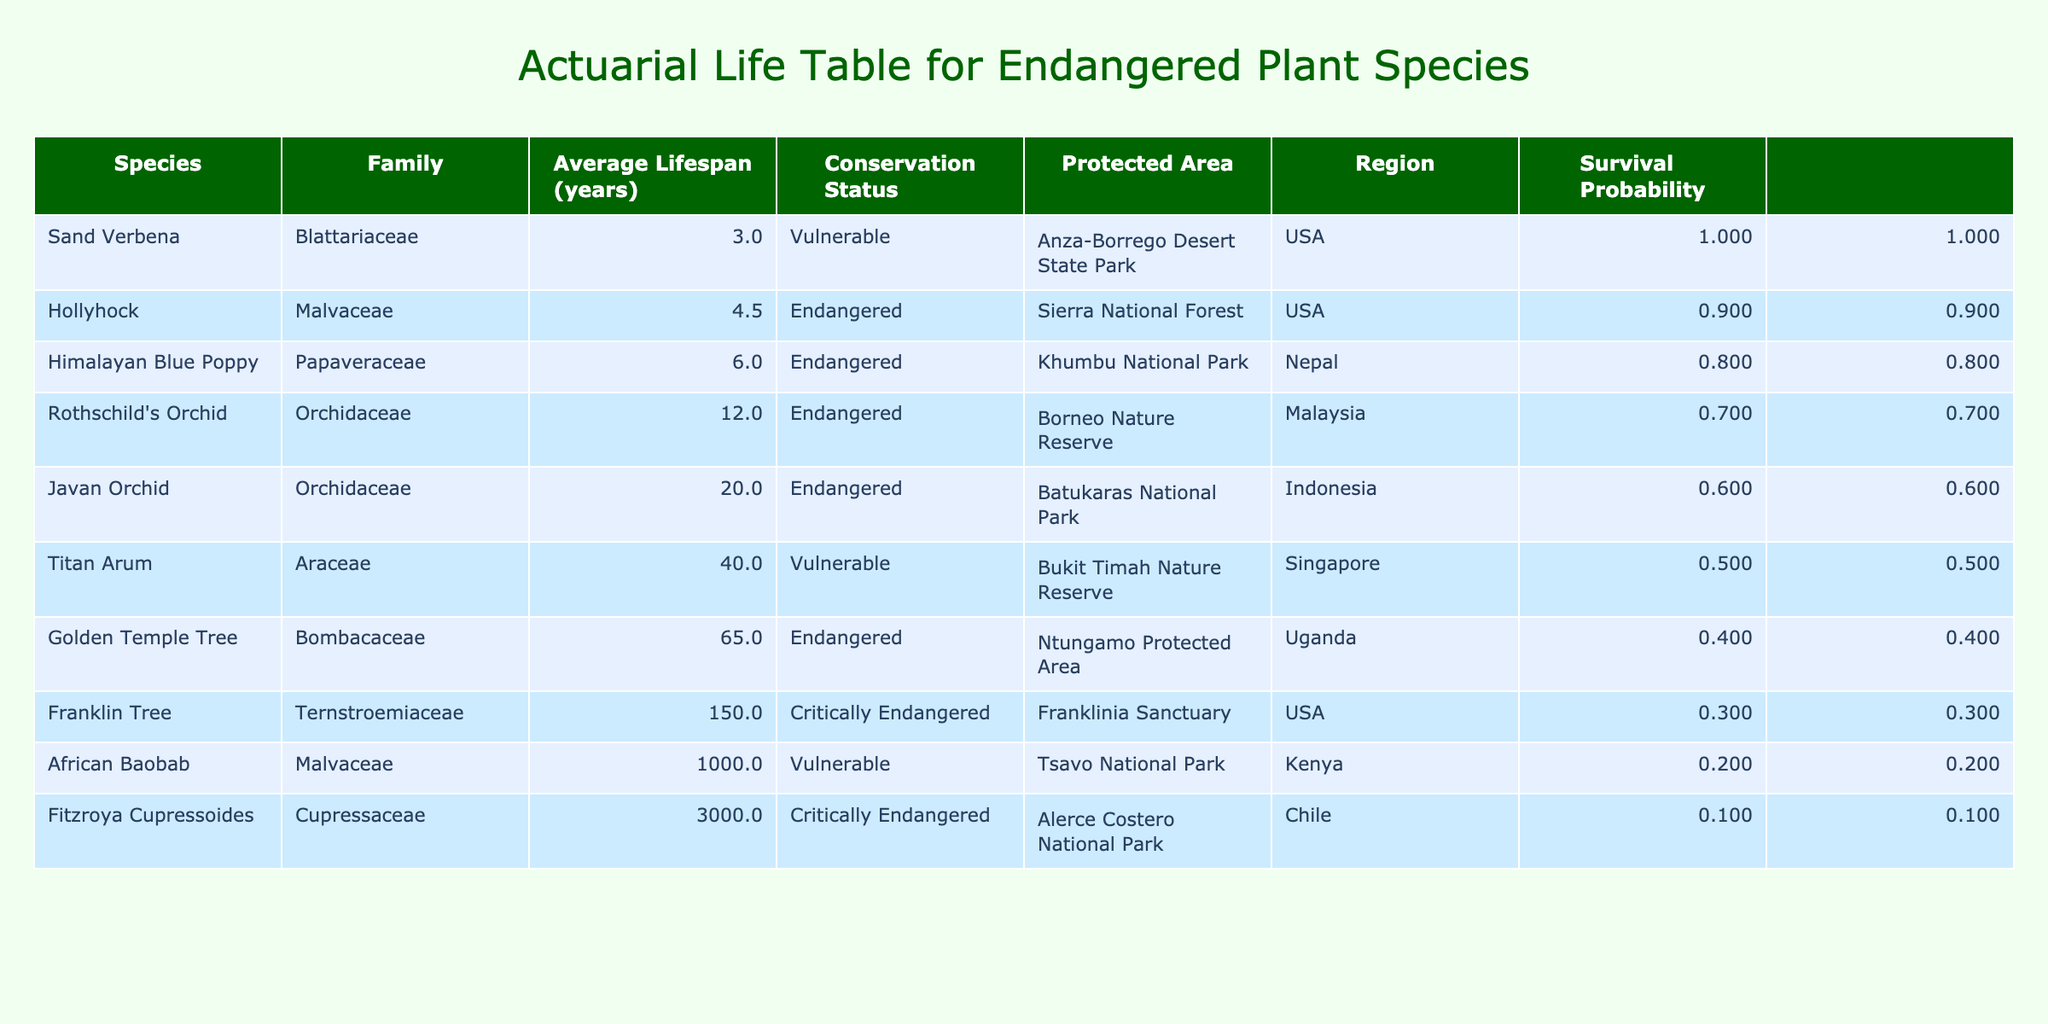What is the average lifespan of the Golden Temple Tree? The Golden Temple Tree is listed in the table with an Average Lifespan of 65.0 years.
Answer: 65.0 years Which plant species has the longest lifespan and what is it? By looking at the table, Fitzroya Cupressoides and the African Baobab have the two longest lifespans at 3000.0 years and 1000.0 years, respectively. The longest is Fitzroya Cupressoides.
Answer: Fitzroya Cupressoides How many species have an average lifespan of less than 10 years? The table includes the Hollyhock (4.5 years), Himalayan Blue Poppy (6.0 years), and Sand Verbena (3.0 years). Adding these three species gives a total of 3 with average lifespans less than 10 years.
Answer: 3 Is there any plant species in the table that is both endangered and has an average lifespan greater than 50 years? The table indicates that the Golden Temple Tree, which is endangered, has an average lifespan of 65.0 years, thus confirming that such a species exists.
Answer: Yes What is the total average lifespan of all the endangered plant species listed? The Average Lifespan for endangered species are: Hollyhock (4.5), Himalayan Blue Poppy (6.0), Rothschild's Orchid (12.0), Javan Orchid (20.0), Golden Temple Tree (65.0), and Franklin Tree (150.0). Adding these gives: 4.5 + 6.0 + 12.0 + 20.0 + 65.0 + 150.0 = 257.5 years. To find the average: 257.5 / 6 = 42.92 years.
Answer: 42.92 years How many species in the table are classified as 'Vulnerable'? According to the data, there are three species labeled as 'Vulnerable': Sand Verbena, African Baobab, and Titan Arum. Therefore, the total count of vulnerable species is 3.
Answer: 3 What is the survival probability of the Franklin Tree? From the ordered table, the Franklin Tree is the species with an average lifespan of 150 years. Its position in the sorted list yields a survival probability corresponding to 5 out of 10 species (or 0.5 rounded) which translates to a probability of 0.500.
Answer: 0.500 